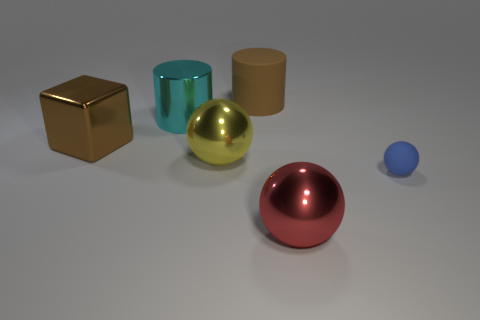Add 1 big red metal objects. How many objects exist? 7 Subtract all cubes. How many objects are left? 5 Subtract all green balls. Subtract all large red metal objects. How many objects are left? 5 Add 5 red shiny things. How many red shiny things are left? 6 Add 1 large brown cylinders. How many large brown cylinders exist? 2 Subtract 0 purple balls. How many objects are left? 6 